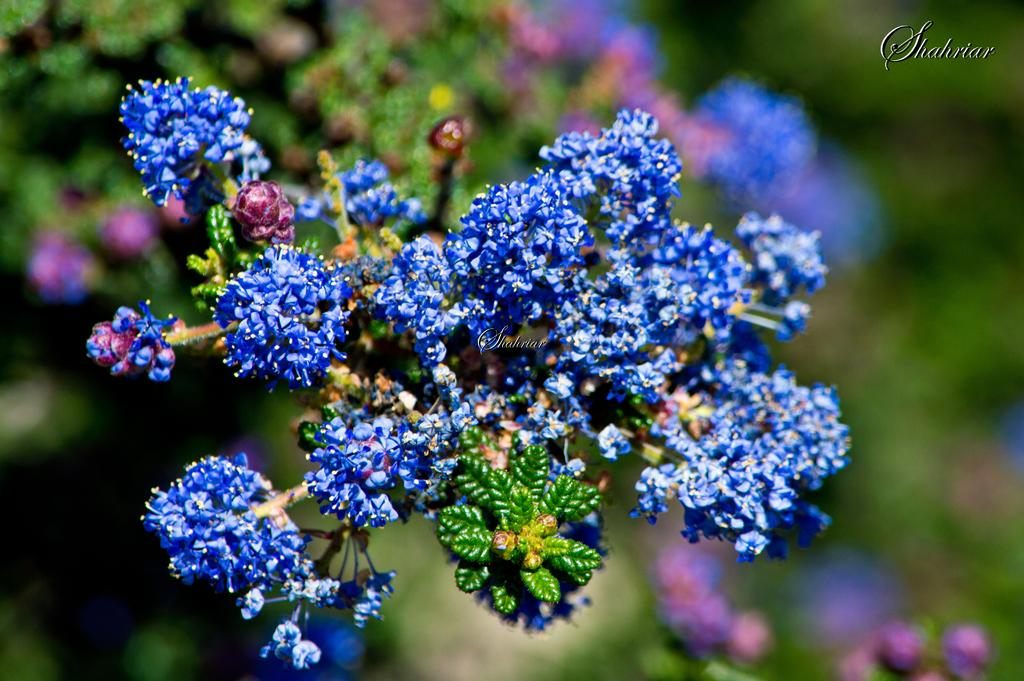What is located in the foreground of the image? There are flowers and leaves in the foreground of the image. Can you describe the background of the image? The background of the image appears blurry. What type of advertisement can be seen in the ocean in the image? There is no ocean or advertisement present in the image; it features flowers and leaves in the foreground and a blurry background. 